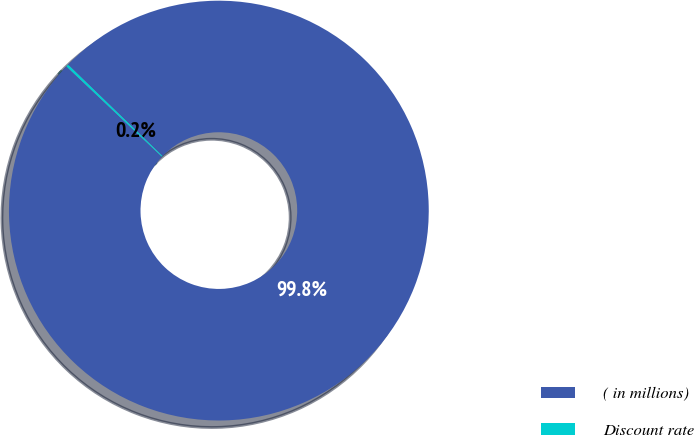Convert chart. <chart><loc_0><loc_0><loc_500><loc_500><pie_chart><fcel>( in millions)<fcel>Discount rate<nl><fcel>99.82%<fcel>0.18%<nl></chart> 